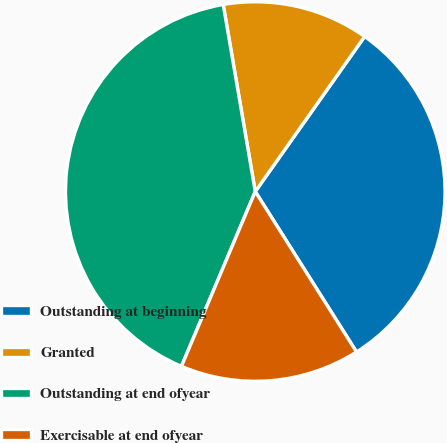Convert chart to OTSL. <chart><loc_0><loc_0><loc_500><loc_500><pie_chart><fcel>Outstanding at beginning<fcel>Granted<fcel>Outstanding at end ofyear<fcel>Exercisable at end ofyear<nl><fcel>31.26%<fcel>12.48%<fcel>40.94%<fcel>15.32%<nl></chart> 